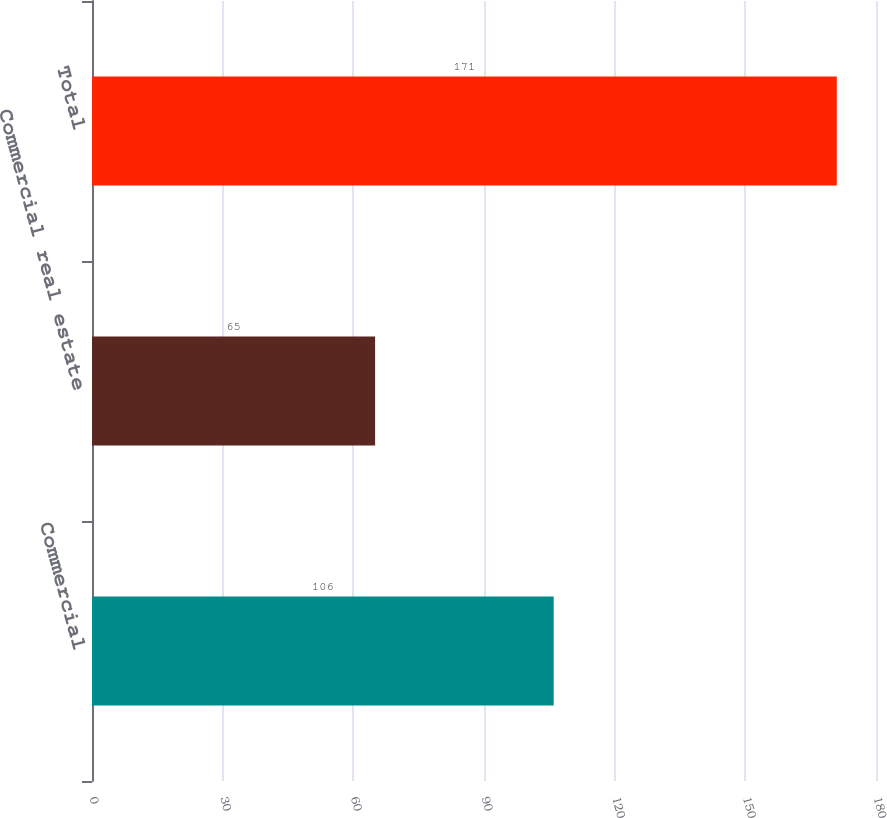Convert chart to OTSL. <chart><loc_0><loc_0><loc_500><loc_500><bar_chart><fcel>Commercial<fcel>Commercial real estate<fcel>Total<nl><fcel>106<fcel>65<fcel>171<nl></chart> 